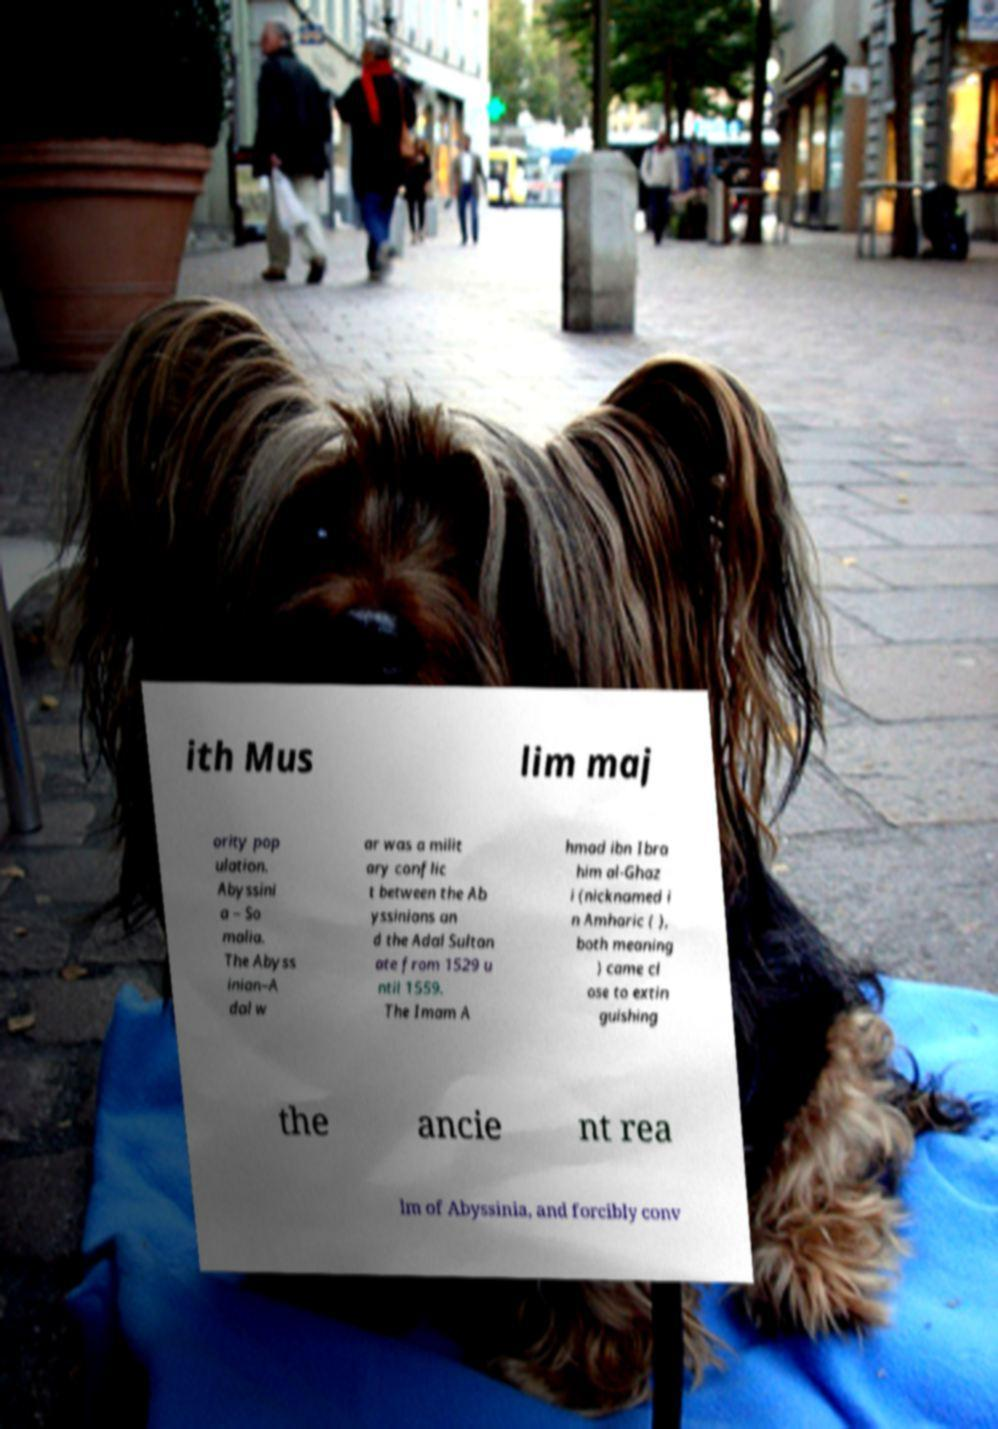Please read and relay the text visible in this image. What does it say? ith Mus lim maj ority pop ulation. Abyssini a – So malia. The Abyss inian–A dal w ar was a milit ary conflic t between the Ab yssinians an d the Adal Sultan ate from 1529 u ntil 1559. The Imam A hmad ibn Ibra him al-Ghaz i (nicknamed i n Amharic ( ), both meaning ) came cl ose to extin guishing the ancie nt rea lm of Abyssinia, and forcibly conv 